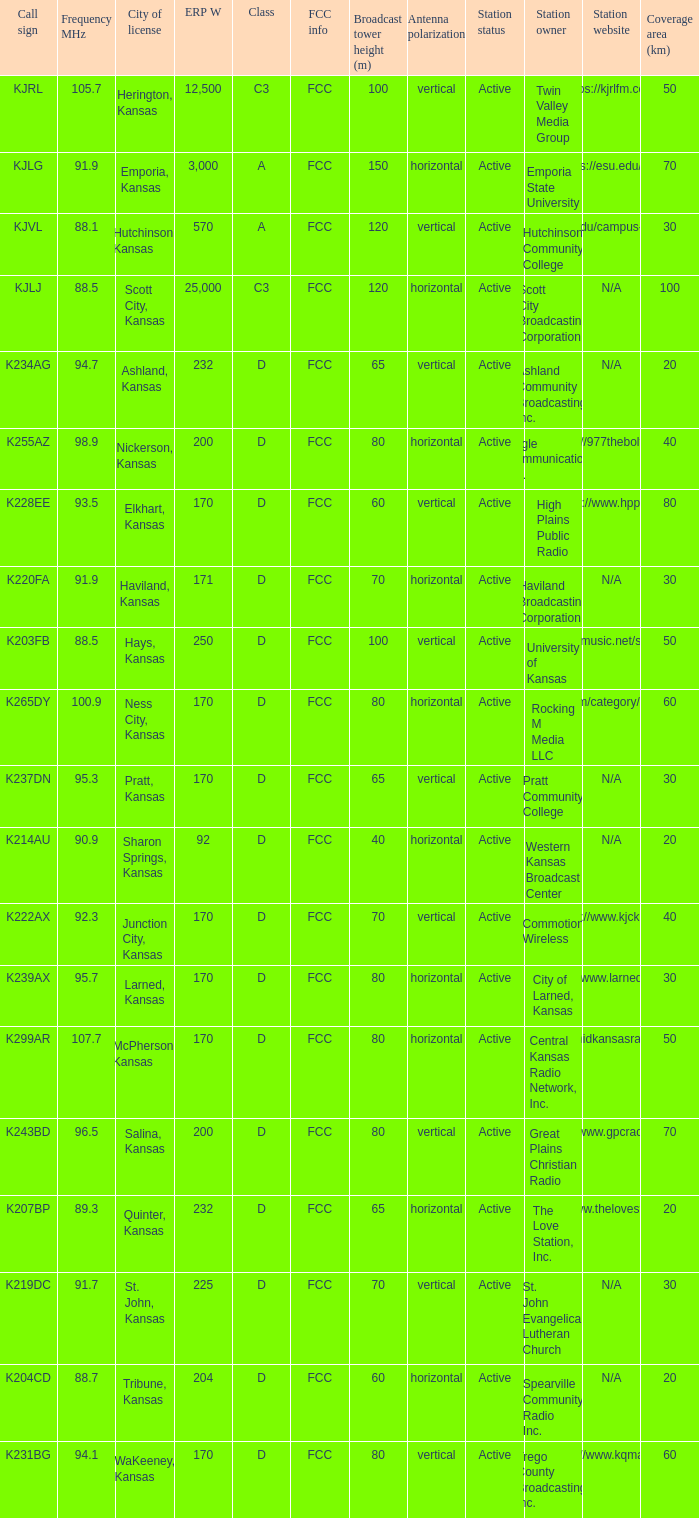Call sign of k231bg has what sum of erp w? 170.0. 